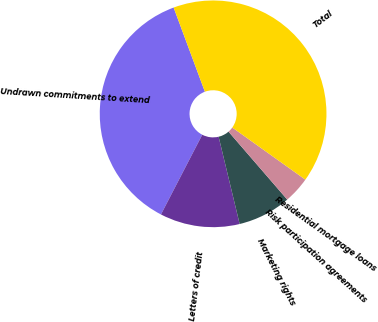Convert chart to OTSL. <chart><loc_0><loc_0><loc_500><loc_500><pie_chart><fcel>Undrawn commitments to extend<fcel>Letters of credit<fcel>Marketing rights<fcel>Risk participation agreements<fcel>Residential mortgage loans<fcel>Total<nl><fcel>36.73%<fcel>11.37%<fcel>7.58%<fcel>3.79%<fcel>0.0%<fcel>40.52%<nl></chart> 